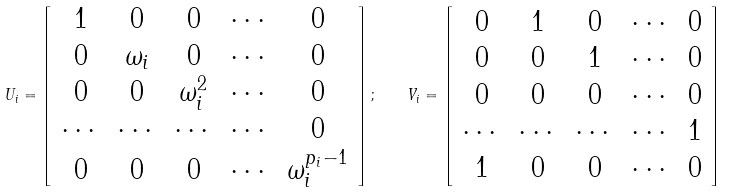Convert formula to latex. <formula><loc_0><loc_0><loc_500><loc_500>U _ { i } = \left [ \begin{array} { c c c c c } 1 & 0 & 0 & \cdots & 0 \\ 0 & \omega _ { i } & 0 & \cdots & 0 \\ 0 & 0 & \omega _ { i } ^ { 2 } & \cdots & 0 \\ \cdots & \cdots & \cdots & \cdots & 0 \\ 0 & 0 & 0 & \cdots & \omega _ { i } ^ { p _ { i } - 1 } \end{array} \right ] ; \quad V _ { i } = \left [ \begin{array} { c c c c c } 0 & 1 & 0 & \cdots & 0 \\ 0 & 0 & 1 & \cdots & 0 \\ 0 & 0 & 0 & \cdots & 0 \\ \cdots & \cdots & \cdots & \cdots & 1 \\ 1 & 0 & 0 & \cdots & 0 \end{array} \right ]</formula> 